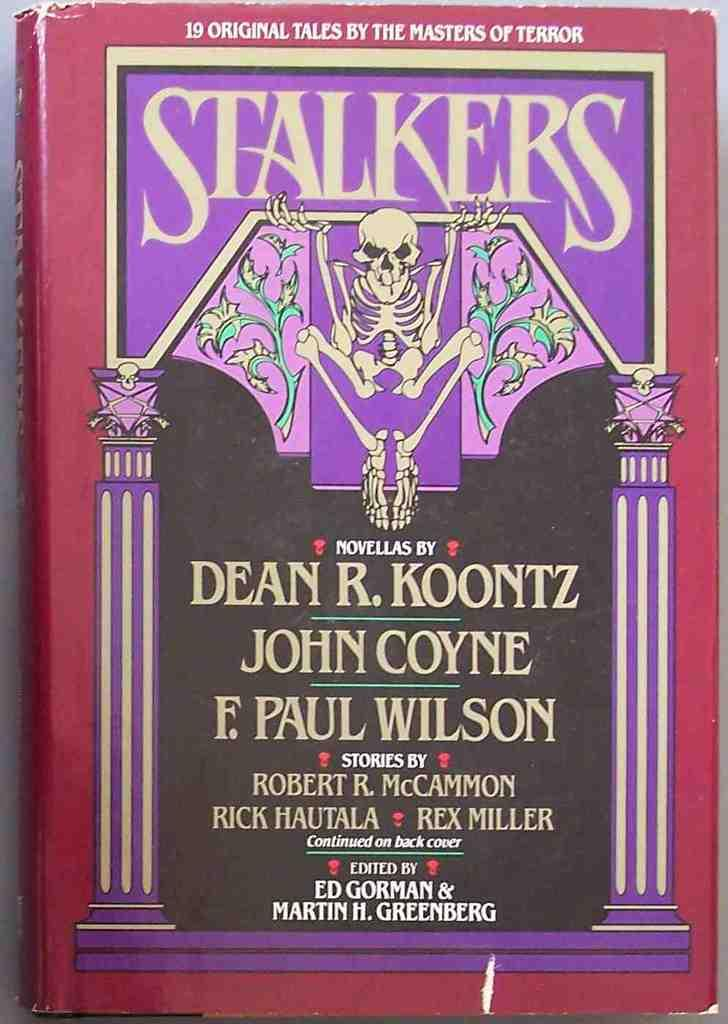<image>
Describe the image concisely. Stalkers book that include nineteen original tales by the masters of terror 